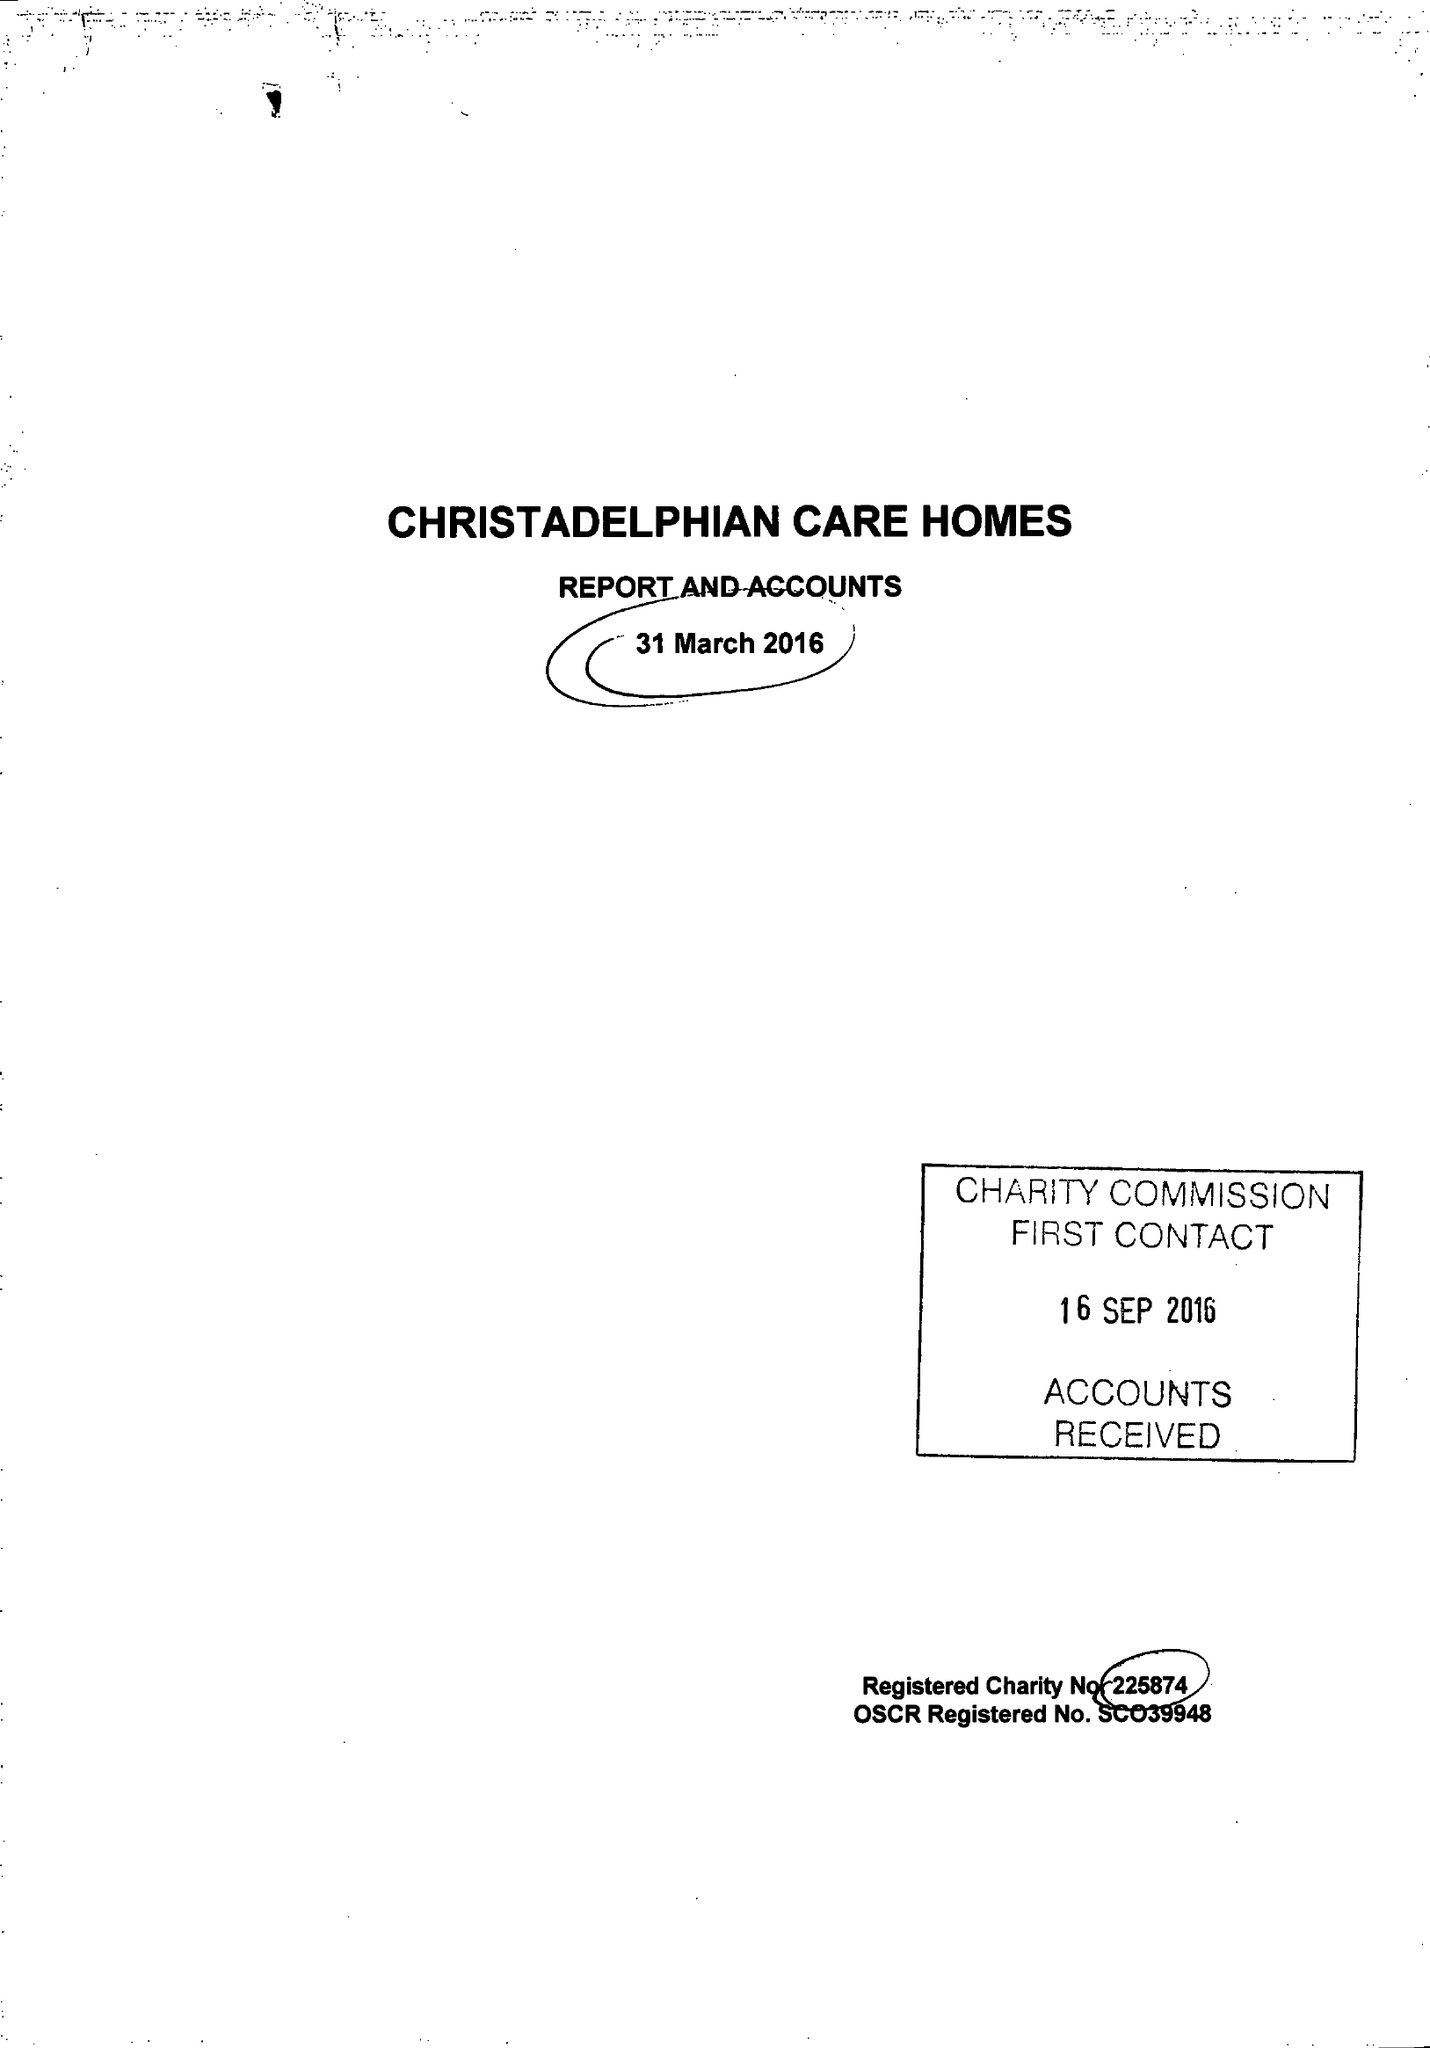What is the value for the income_annually_in_british_pounds?
Answer the question using a single word or phrase. 10913293.00 